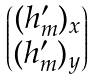<formula> <loc_0><loc_0><loc_500><loc_500>\begin{pmatrix} ( h ^ { \prime } _ { m } ) _ { x } \\ ( h ^ { \prime } _ { m } ) _ { y } \end{pmatrix}</formula> 